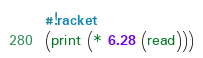<code> <loc_0><loc_0><loc_500><loc_500><_Racket_>#!racket
(print (* 6.28 (read)))</code> 